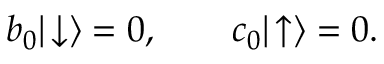Convert formula to latex. <formula><loc_0><loc_0><loc_500><loc_500>b _ { 0 } | \, \downarrow \rangle = 0 , \quad c _ { 0 } | \, \uparrow \rangle = 0 .</formula> 